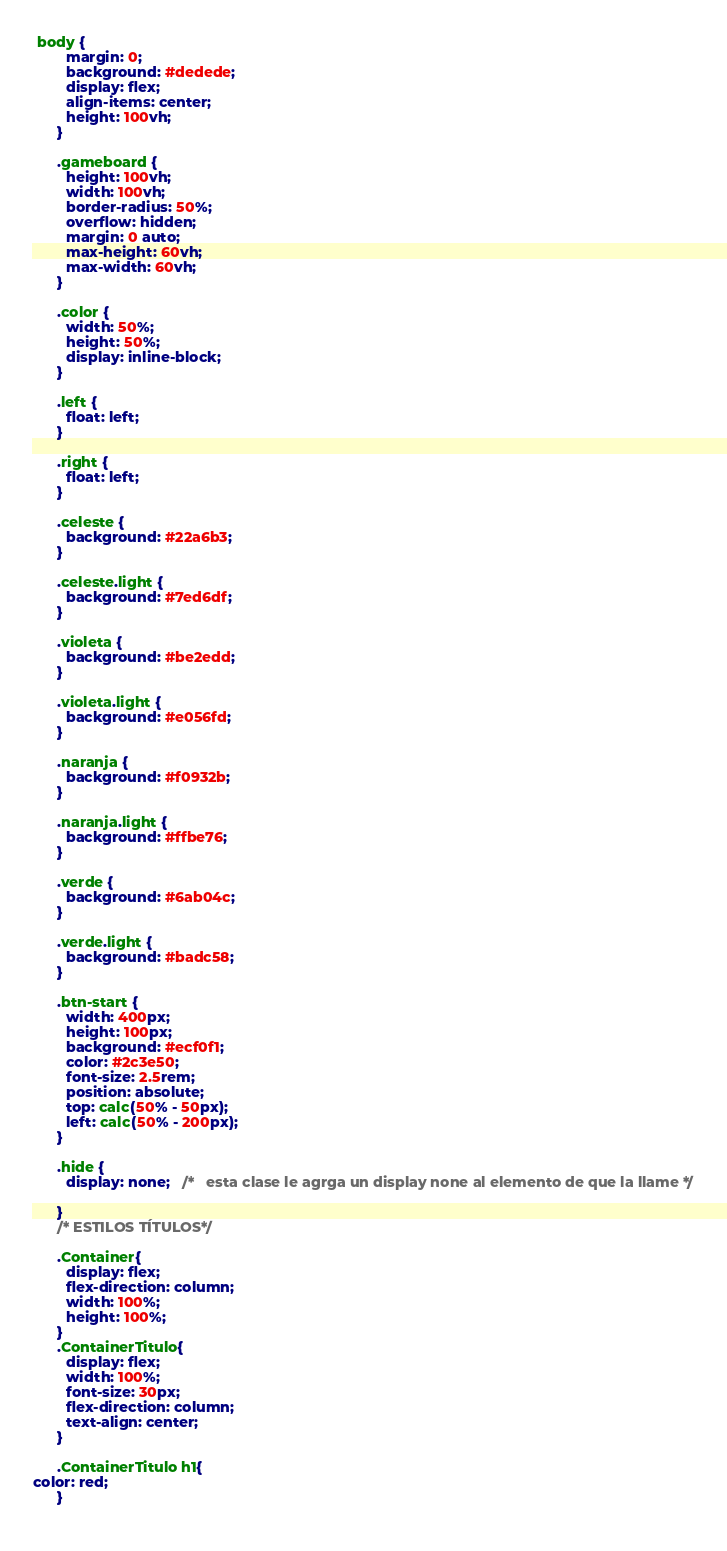Convert code to text. <code><loc_0><loc_0><loc_500><loc_500><_CSS_>
 body {
        margin: 0;
        background: #dedede;
        display: flex;
        align-items: center;
        height: 100vh;
      }

      .gameboard {
        height: 100vh;
        width: 100vh;
        border-radius: 50%;
        overflow: hidden;
        margin: 0 auto;
        max-height: 60vh; 
        max-width: 60vh;
      }

      .color {
        width: 50%;
        height: 50%;
        display: inline-block;
      }

      .left {
        float: left;
      }

      .right {
        float: left;
      }

      .celeste {
        background: #22a6b3;
      }

      .celeste.light {
        background: #7ed6df;
      }

      .violeta {
        background: #be2edd;
      }

      .violeta.light {
        background: #e056fd;
      }

      .naranja {
        background: #f0932b;
      }

      .naranja.light {
        background: #ffbe76;
      }

      .verde {
        background: #6ab04c;
      }

      .verde.light {
        background: #badc58;
      }

      .btn-start {
        width: 400px;
        height: 100px;
        background: #ecf0f1;
        color: #2c3e50;
        font-size: 2.5rem;
        position: absolute;
        top: calc(50% - 50px);
        left: calc(50% - 200px);
      }

      .hide {
        display: none;   /*   esta clase le agrga un display none al elemento de que la llame */

      }
      /* ESTILOS TÍTULOS*/

      .Container{
        display: flex;
        flex-direction: column;
        width: 100%;
        height: 100%;
      }
      .ContainerTitulo{
        display: flex;
        width: 100%;
        font-size: 30px;
        flex-direction: column;
        text-align: center;
      }

      .ContainerTitulo h1{
color: red;
      }
      </code> 